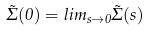Convert formula to latex. <formula><loc_0><loc_0><loc_500><loc_500>\tilde { \Sigma } ( 0 ) = l i m _ { s \rightarrow 0 } \tilde { \Sigma } ( s )</formula> 